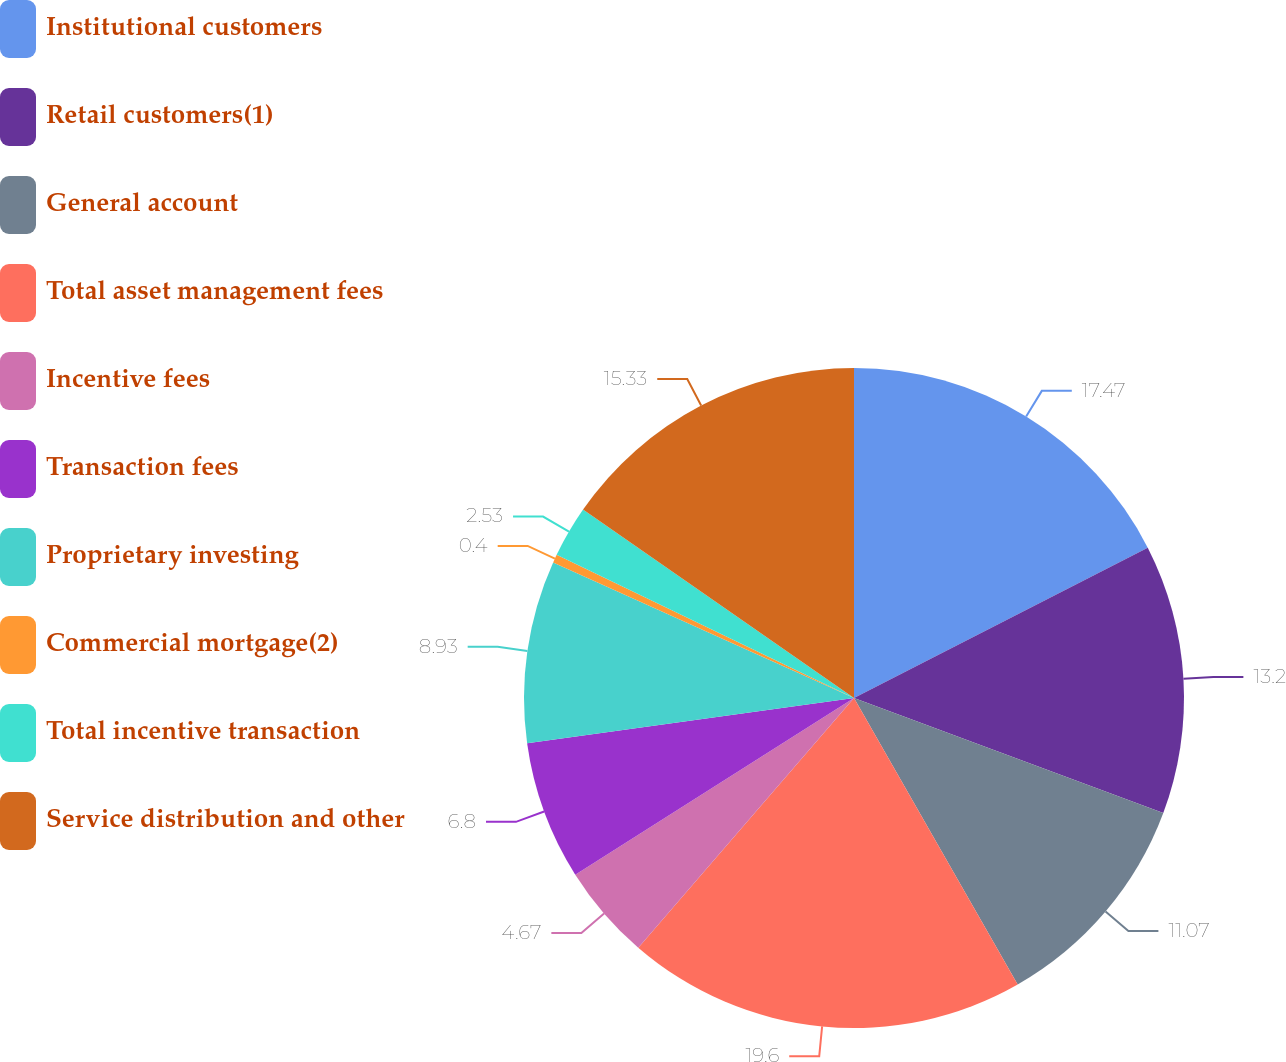<chart> <loc_0><loc_0><loc_500><loc_500><pie_chart><fcel>Institutional customers<fcel>Retail customers(1)<fcel>General account<fcel>Total asset management fees<fcel>Incentive fees<fcel>Transaction fees<fcel>Proprietary investing<fcel>Commercial mortgage(2)<fcel>Total incentive transaction<fcel>Service distribution and other<nl><fcel>17.47%<fcel>13.2%<fcel>11.07%<fcel>19.6%<fcel>4.67%<fcel>6.8%<fcel>8.93%<fcel>0.4%<fcel>2.53%<fcel>15.33%<nl></chart> 